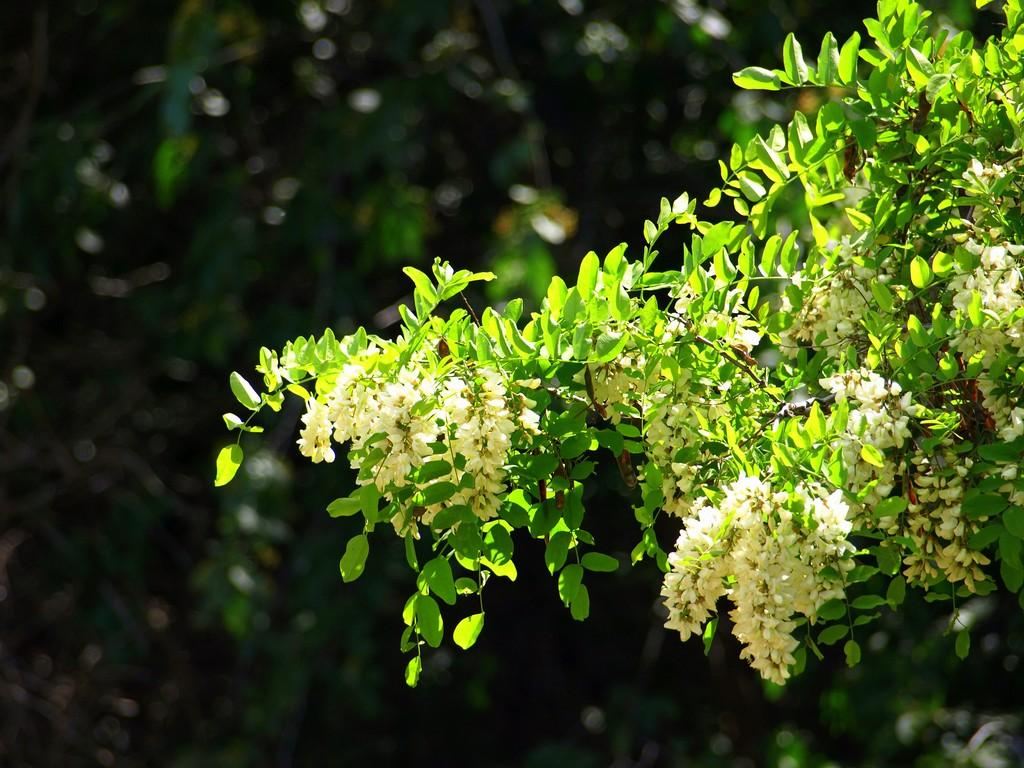What type of plants can be seen in the image? There are flowers and leaves in the image. What can be seen in the background of the image? There are trees in the background of the image. How would you describe the background of the image? The background of the image is blurry. How does the sack contribute to the stability of the trees during the earthquake in the image? There is no sack or earthquake present in the image. The image features flowers, leaves, trees, and a blurry background. 